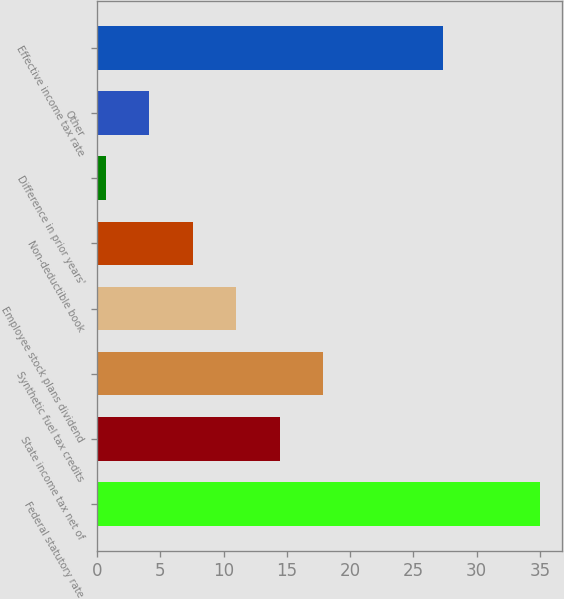<chart> <loc_0><loc_0><loc_500><loc_500><bar_chart><fcel>Federal statutory rate<fcel>State income tax net of<fcel>Synthetic fuel tax credits<fcel>Employee stock plans dividend<fcel>Non-deductible book<fcel>Difference in prior years'<fcel>Other<fcel>Effective income tax rate<nl><fcel>35<fcel>14.42<fcel>17.85<fcel>10.99<fcel>7.56<fcel>0.7<fcel>4.13<fcel>27.3<nl></chart> 